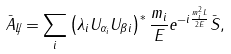<formula> <loc_0><loc_0><loc_500><loc_500>\bar { A } _ { \not { L } } = \sum _ { i } \left ( \lambda _ { i } U _ { \alpha _ { i } } U _ { \beta i } \right ) ^ { * } \frac { m _ { i } } { E } e ^ { - i \frac { m _ { i } ^ { 2 } L } { 2 E } } \bar { S } ,</formula> 